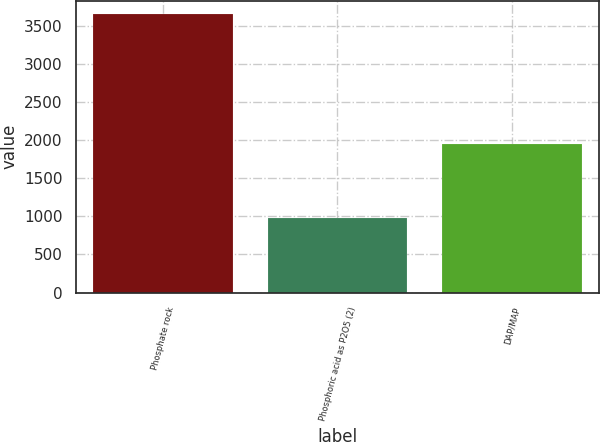<chart> <loc_0><loc_0><loc_500><loc_500><bar_chart><fcel>Phosphate rock<fcel>Phosphoric acid as P2O5 (2)<fcel>DAP/MAP<nl><fcel>3647<fcel>978<fcel>1945<nl></chart> 